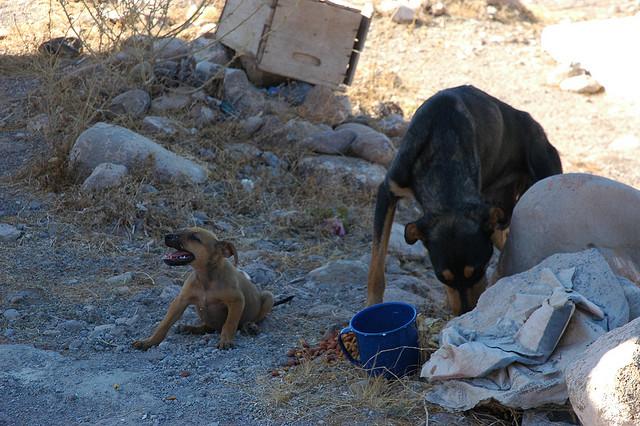What animals are photographed?
Be succinct. Dogs. Is there a puppy in this picture?
Concise answer only. Yes. How many dogs can be seen?
Keep it brief. 2. 